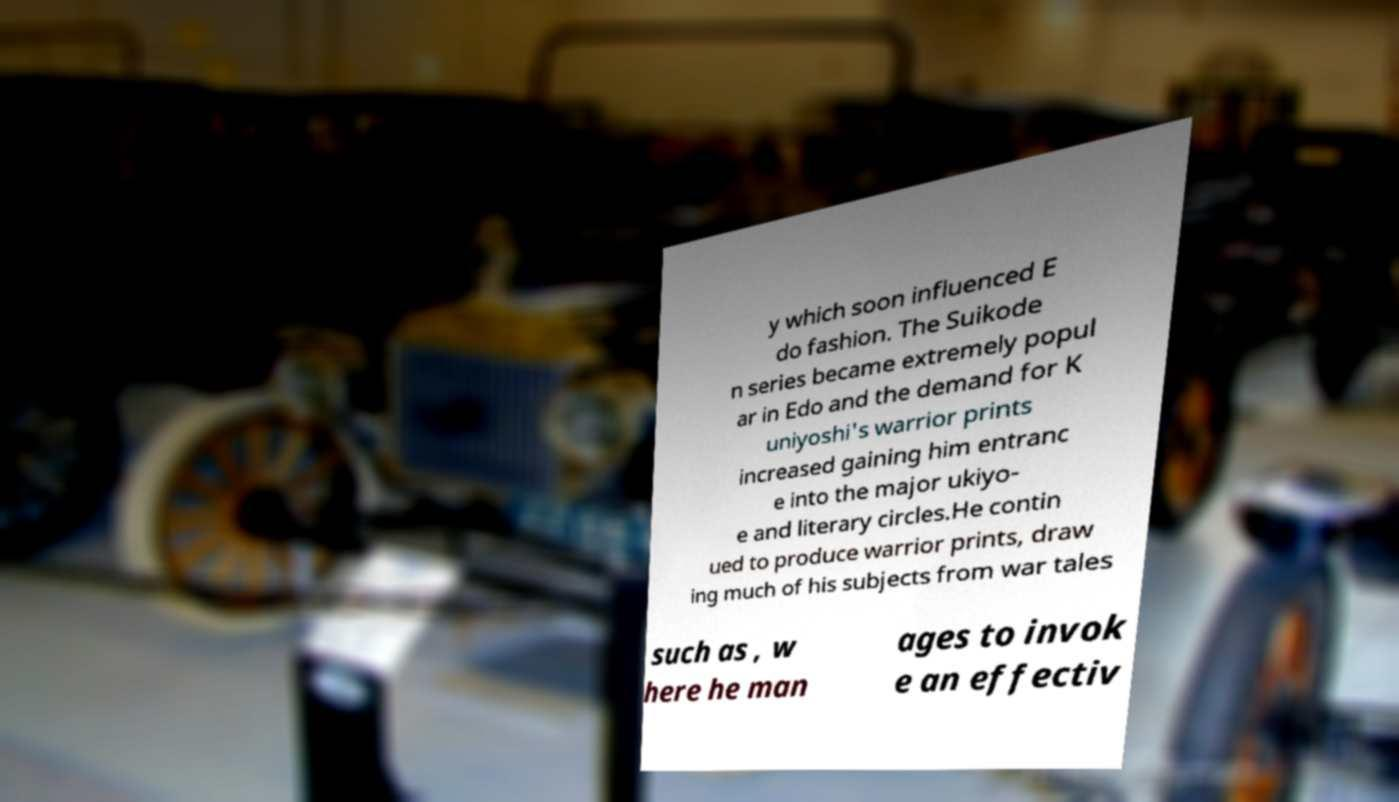Please identify and transcribe the text found in this image. y which soon influenced E do fashion. The Suikode n series became extremely popul ar in Edo and the demand for K uniyoshi's warrior prints increased gaining him entranc e into the major ukiyo- e and literary circles.He contin ued to produce warrior prints, draw ing much of his subjects from war tales such as , w here he man ages to invok e an effectiv 